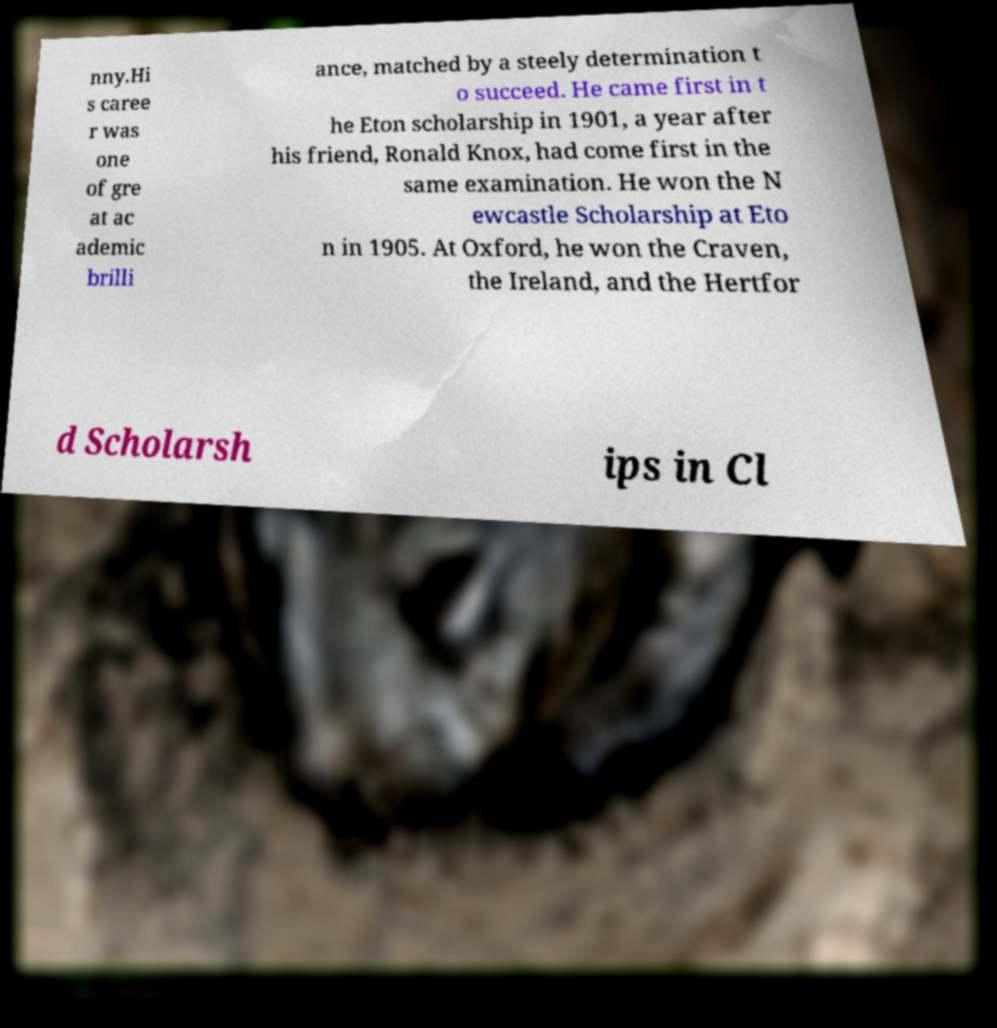What messages or text are displayed in this image? I need them in a readable, typed format. nny.Hi s caree r was one of gre at ac ademic brilli ance, matched by a steely determination t o succeed. He came first in t he Eton scholarship in 1901, a year after his friend, Ronald Knox, had come first in the same examination. He won the N ewcastle Scholarship at Eto n in 1905. At Oxford, he won the Craven, the Ireland, and the Hertfor d Scholarsh ips in Cl 